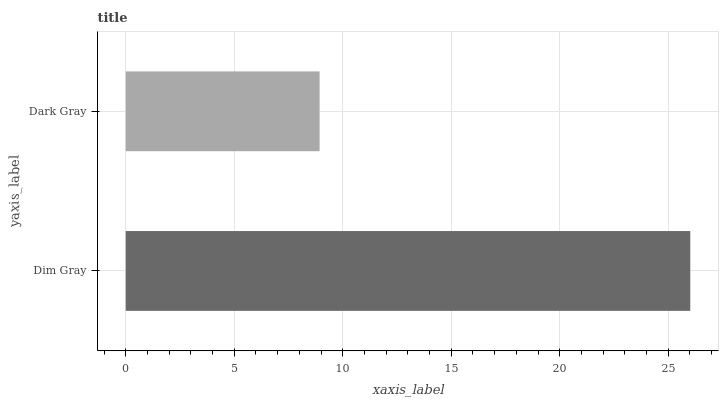Is Dark Gray the minimum?
Answer yes or no. Yes. Is Dim Gray the maximum?
Answer yes or no. Yes. Is Dark Gray the maximum?
Answer yes or no. No. Is Dim Gray greater than Dark Gray?
Answer yes or no. Yes. Is Dark Gray less than Dim Gray?
Answer yes or no. Yes. Is Dark Gray greater than Dim Gray?
Answer yes or no. No. Is Dim Gray less than Dark Gray?
Answer yes or no. No. Is Dim Gray the high median?
Answer yes or no. Yes. Is Dark Gray the low median?
Answer yes or no. Yes. Is Dark Gray the high median?
Answer yes or no. No. Is Dim Gray the low median?
Answer yes or no. No. 